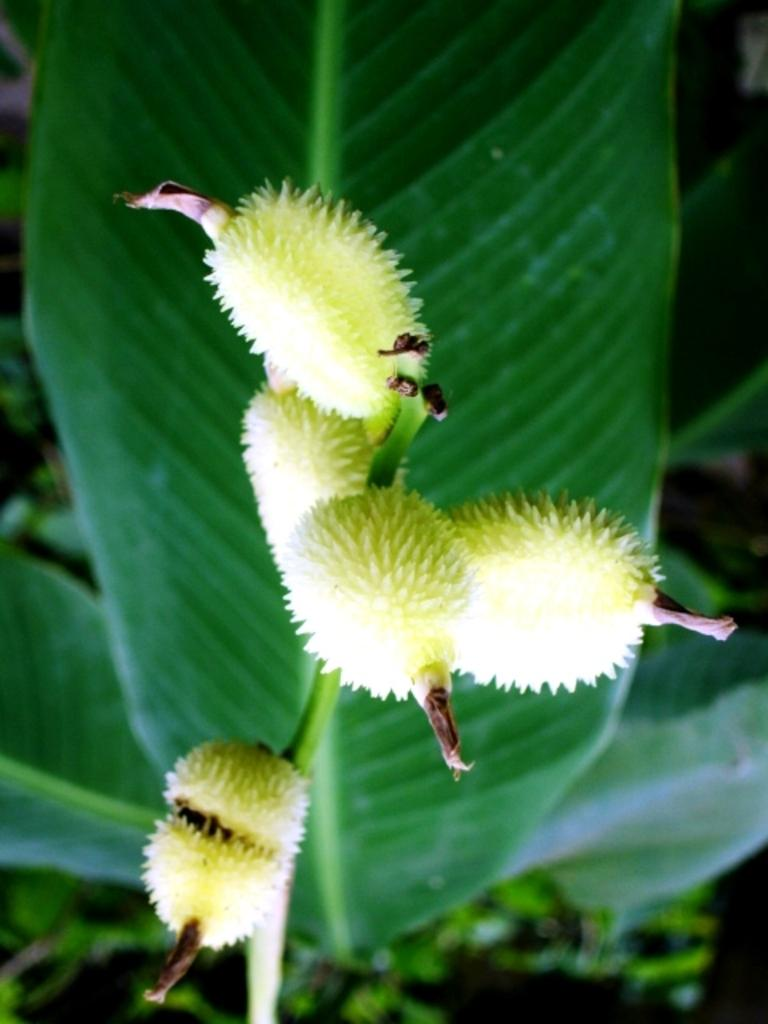What type of living organisms can be seen in the image? Plants can be seen in the image. What can be found in the image that might be used for plant reproduction or growth? There are seeds in the image. How many chickens are present in the image? There are no chickens present in the image; it only features plants and seeds. What type of power source is visible in the image? There is no power source visible in the image; it only features plants and seeds. 